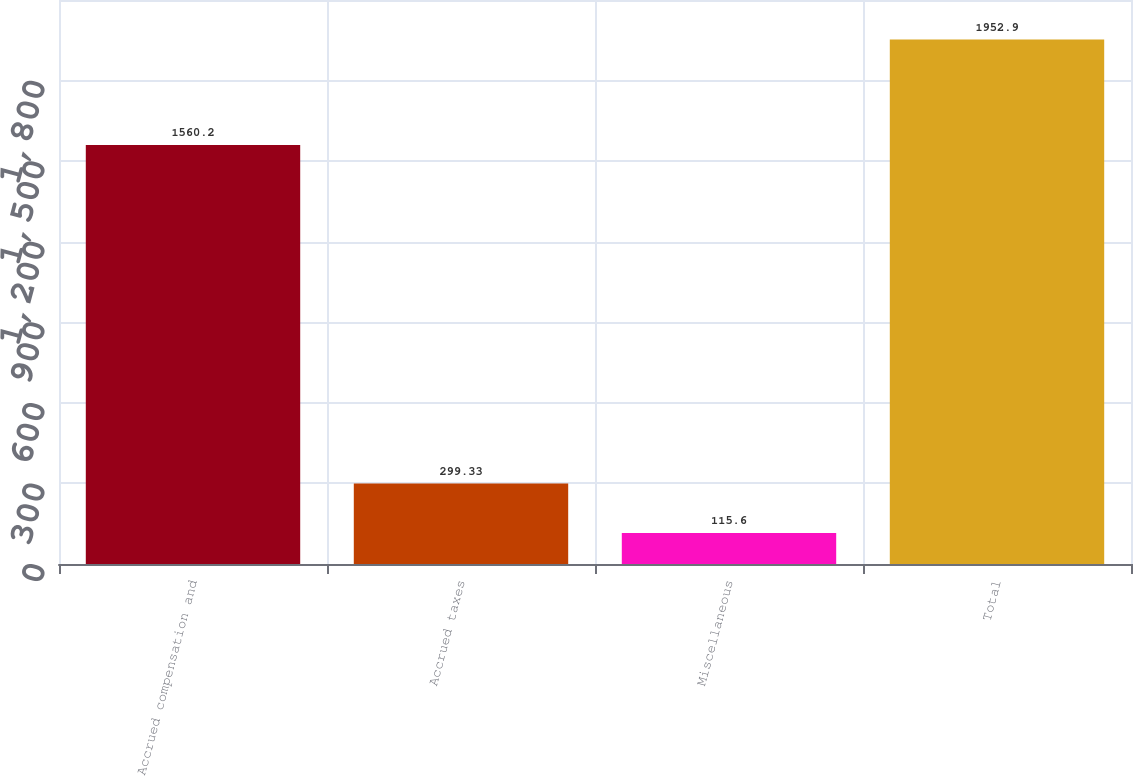Convert chart. <chart><loc_0><loc_0><loc_500><loc_500><bar_chart><fcel>Accrued compensation and<fcel>Accrued taxes<fcel>Miscellaneous<fcel>Total<nl><fcel>1560.2<fcel>299.33<fcel>115.6<fcel>1952.9<nl></chart> 